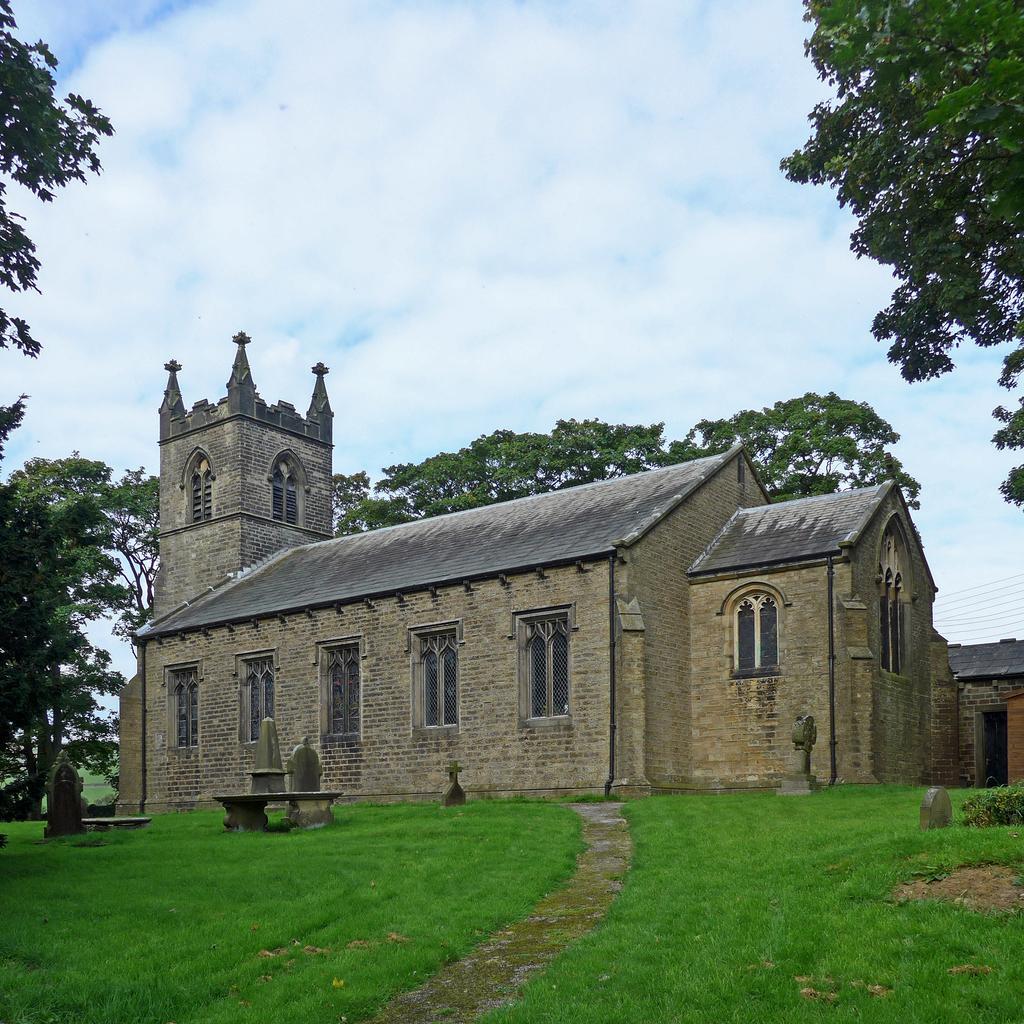Describe this image in one or two sentences. In this image there is a building. There is grass. There are trees in the background. There is a sky. There are some objects in front of the building. 